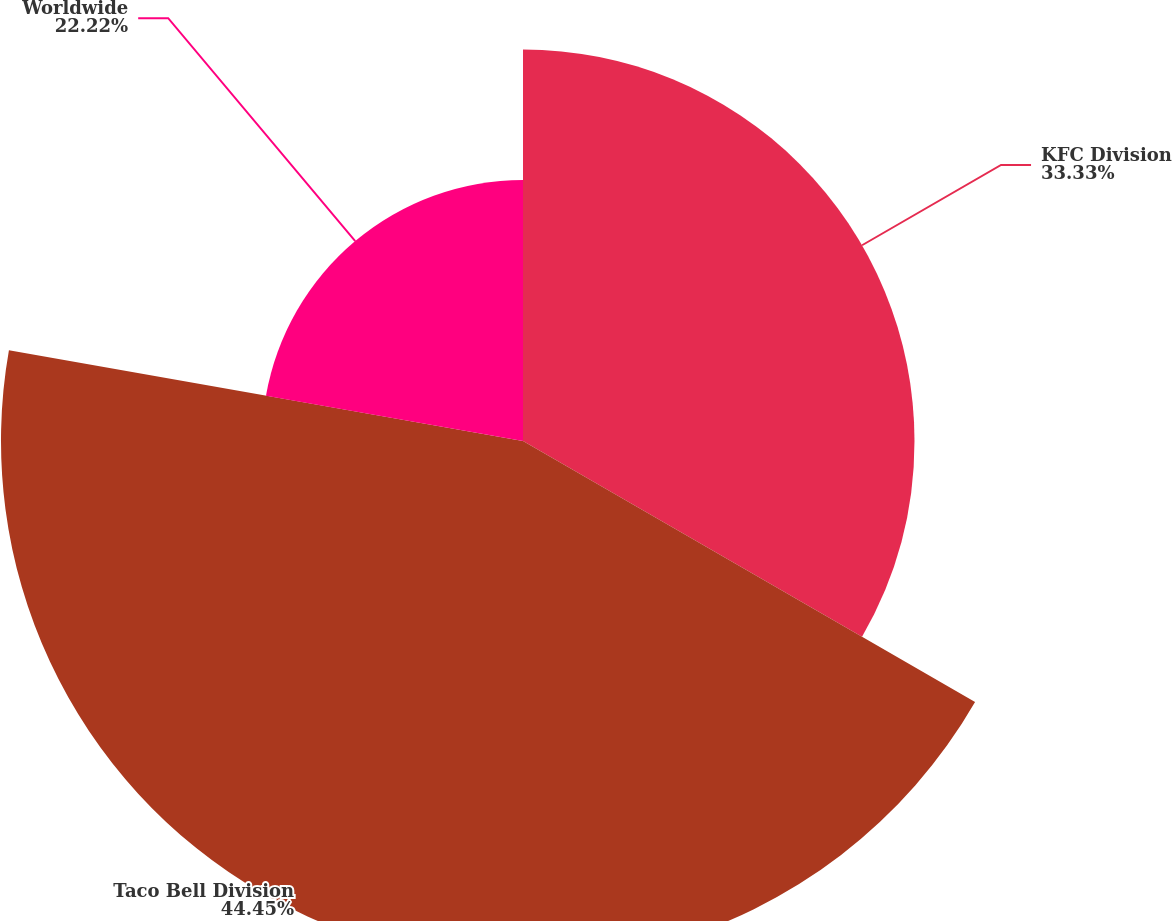Convert chart to OTSL. <chart><loc_0><loc_0><loc_500><loc_500><pie_chart><fcel>KFC Division<fcel>Taco Bell Division<fcel>Worldwide<nl><fcel>33.33%<fcel>44.44%<fcel>22.22%<nl></chart> 